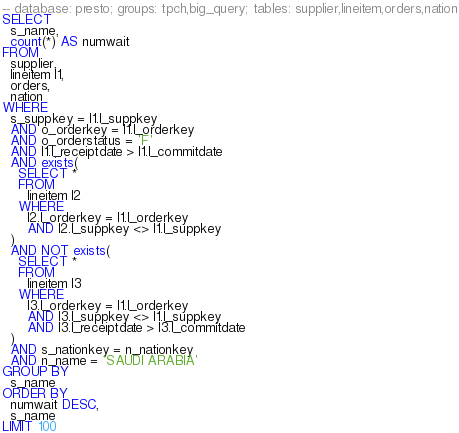<code> <loc_0><loc_0><loc_500><loc_500><_SQL_>-- database: presto; groups: tpch,big_query; tables: supplier,lineitem,orders,nation
SELECT
  s_name,
  count(*) AS numwait
FROM
  supplier,
  lineitem l1,
  orders,
  nation
WHERE
  s_suppkey = l1.l_suppkey
  AND o_orderkey = l1.l_orderkey
  AND o_orderstatus = 'F'
  AND l1.l_receiptdate > l1.l_commitdate
  AND exists(
    SELECT *
    FROM
      lineitem l2
    WHERE
      l2.l_orderkey = l1.l_orderkey
      AND l2.l_suppkey <> l1.l_suppkey
  )
  AND NOT exists(
    SELECT *
    FROM
      lineitem l3
    WHERE
      l3.l_orderkey = l1.l_orderkey
      AND l3.l_suppkey <> l1.l_suppkey
      AND l3.l_receiptdate > l3.l_commitdate
  )
  AND s_nationkey = n_nationkey
  AND n_name = 'SAUDI ARABIA'
GROUP BY
  s_name
ORDER BY
  numwait DESC,
  s_name
LIMIT 100
</code> 